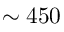Convert formula to latex. <formula><loc_0><loc_0><loc_500><loc_500>\sim 4 5 0</formula> 